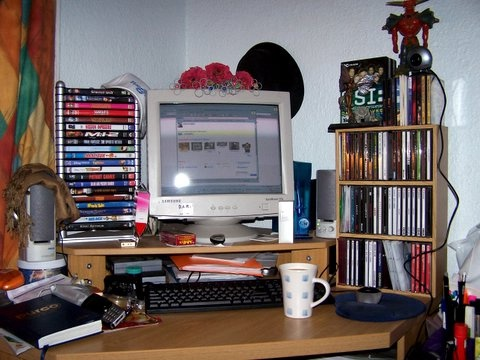Describe the objects in this image and their specific colors. I can see book in black, gray, darkgray, and lightgray tones, tv in black, darkgray, gray, and lightgray tones, keyboard in black and gray tones, cup in black, lightgray, and darkgray tones, and book in black, lightpink, and brown tones in this image. 